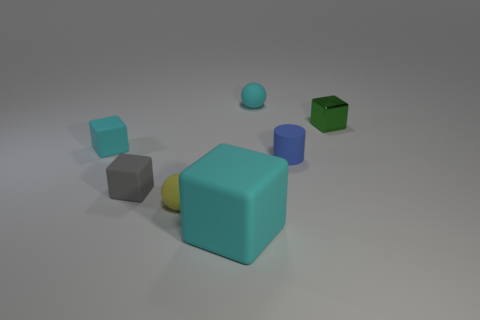Does the cyan rubber cube in front of the gray block have the same size as the small gray object? No, the cyan rubber cube in front of the gray block is larger than the small gray object. While they both are cube-shaped, the cyan cube has a larger volume, noticeably bigger when comparing their dimensions. 